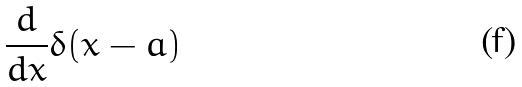Convert formula to latex. <formula><loc_0><loc_0><loc_500><loc_500>\frac { d } { d x } \delta ( x - a )</formula> 